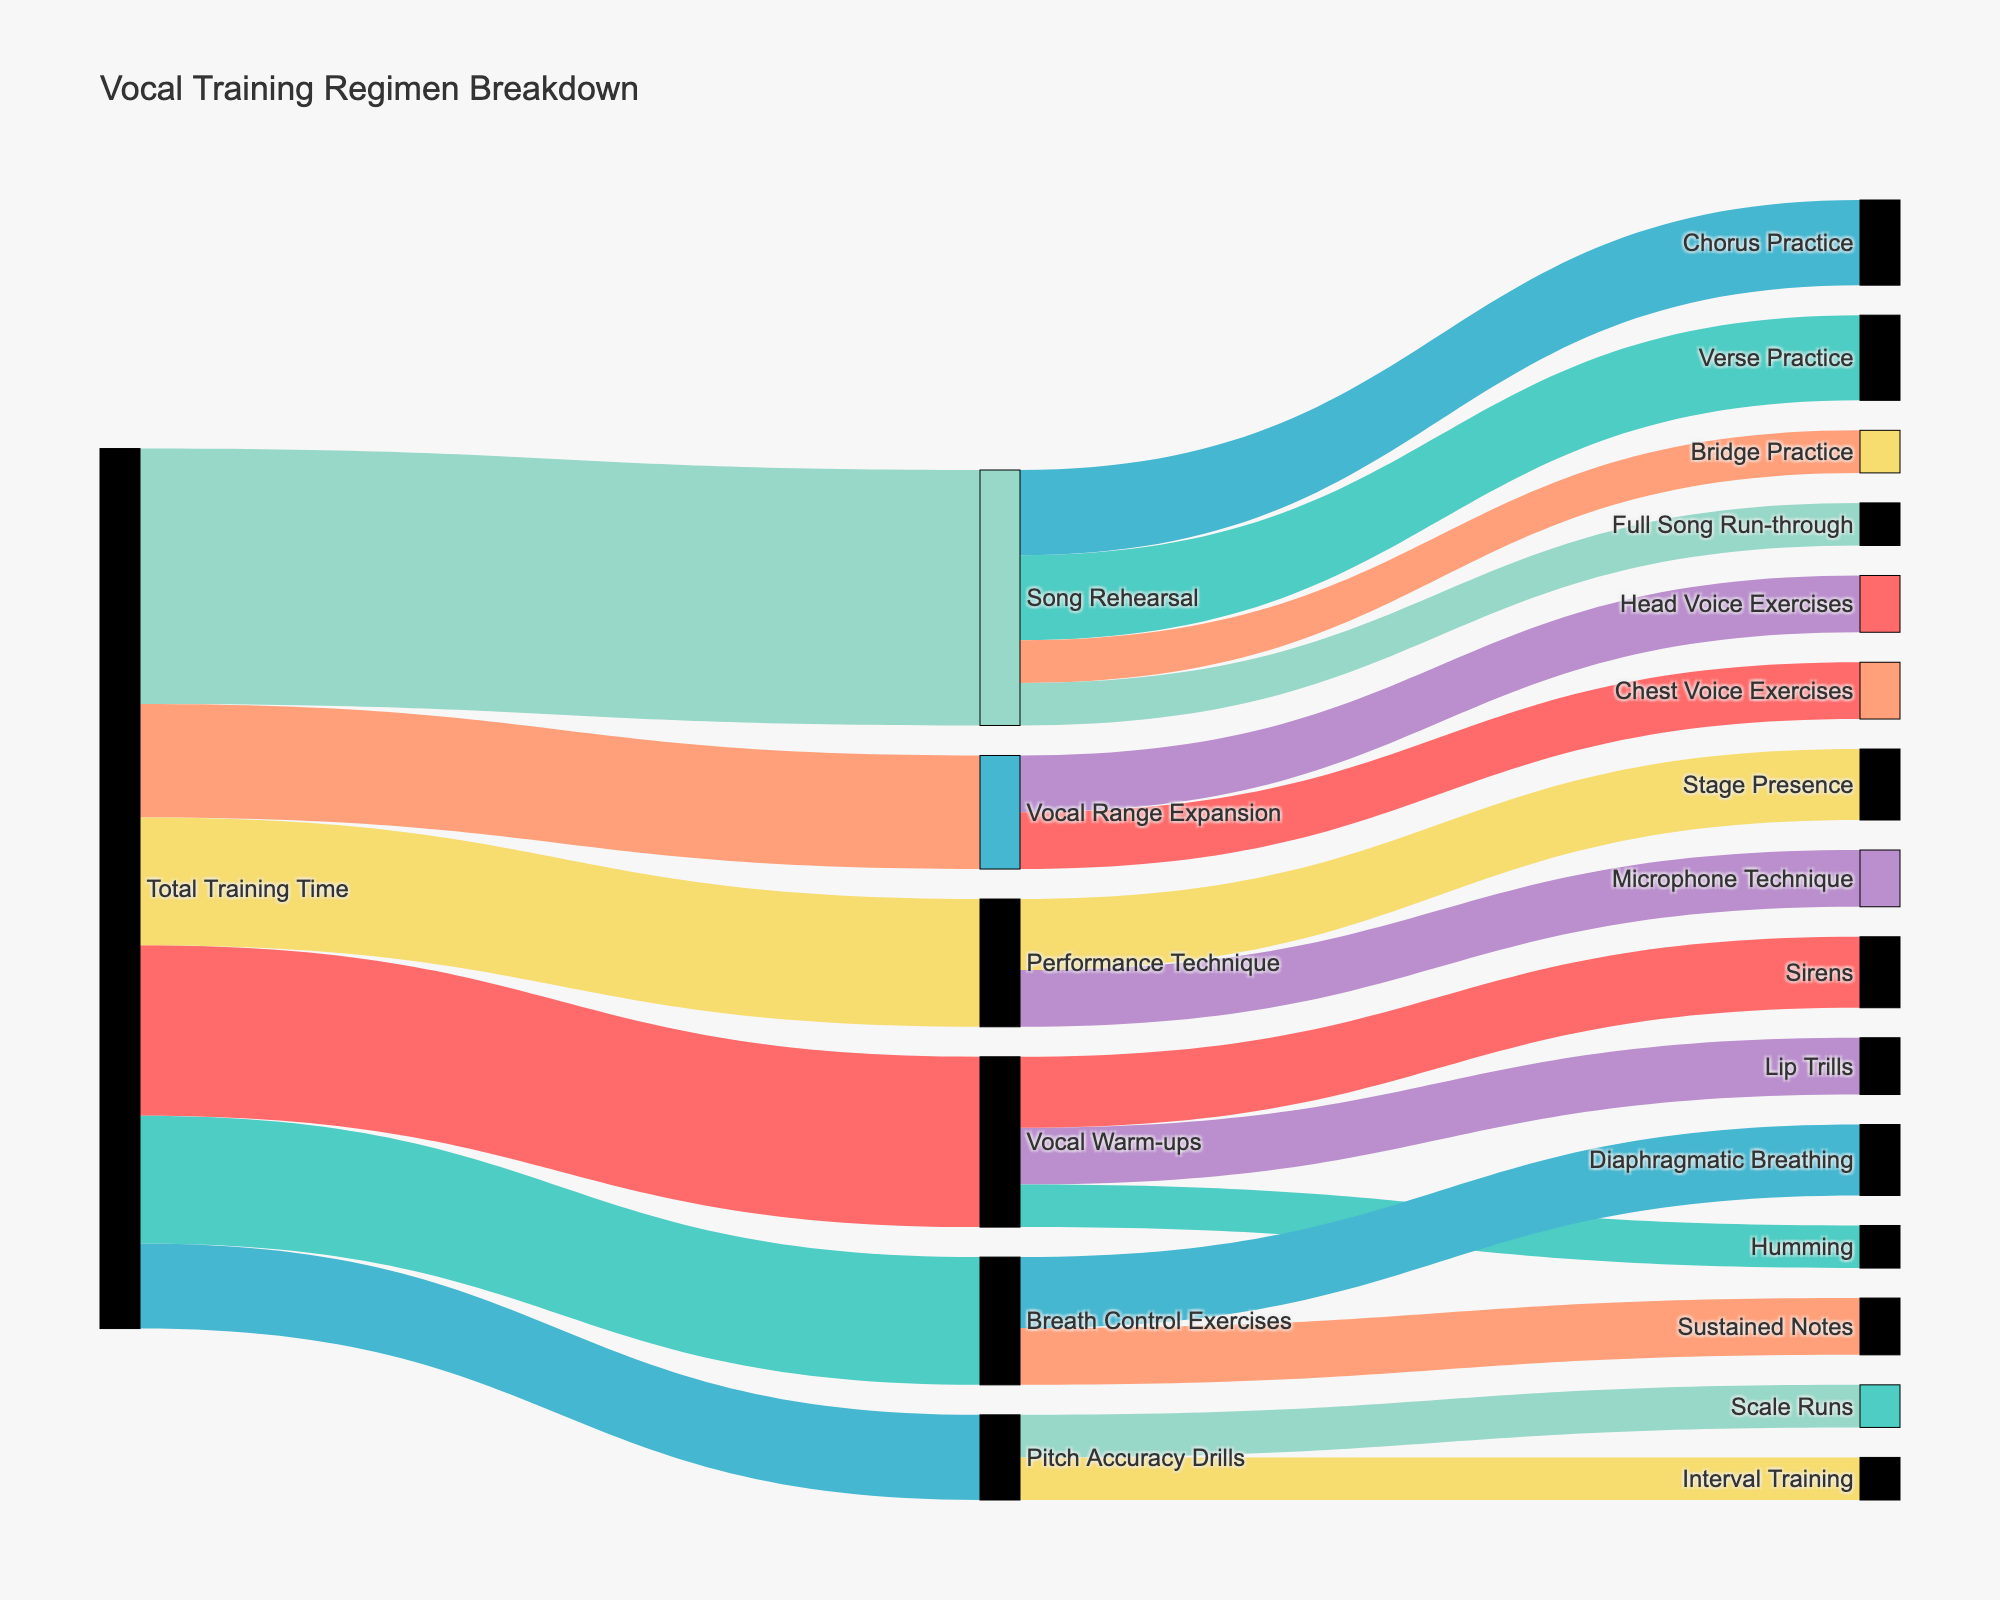what is the total time allocated to Song Rehearsal? Review the "Total Training Time" node that splits into different activities. Sum the values leading into Song Rehearsal: Verse Practice (30), Chorus Practice (30), Bridge Practice (15), and Full Song Run-through (15); total is 30 + 30 + 15 + 15 = 90 minutes.
Answer: 90 minutes Which specific exercise takes the most time under Vocal Warm-ups? Look into the breakdown of Vocal Warm-ups, which splits into Lip Trills, Sirens, and Humming. The time for each is: Lip Trills (20), Sirens (25), and Humming (15). Sirens have the highest value of 25 minutes.
Answer: Sirens Compare the time allocated to Performance Technique and Breath Control Exercises. Which one has more time and by how much? Check the values assigned to Performance Technique (45 minutes) and Breath Control Exercises (45 minutes). Both are allocated the same time.
Answer: Equal, 0 minutes How much total time is dedicated to vocal techniques excluding Song Rehearsal and Performance Technique? Among the main techniques, exclude Song Rehearsal and Performance Technique. Sum the remaining: Vocal Warm-ups (60), Breath Control Exercises (45), Pitch Accuracy Drills (30), Vocal Range Expansion (40). Total is: 60 + 45 + 30 + 40 = 175 minutes.
Answer: 175 minutes What's the combined time set for Pitch Accuracy Drills and Vocal Range Expansion? Identify Pitch Accuracy Drills (30 minutes) and Vocal Range Expansion (40 minutes). Add both values: 30 + 40 = 70 minutes.
Answer: 70 minutes How does time allocated to Lip Trills compare with time allocated to Diaphragmatic Breathing? Check the values for Lip Trills (20 minutes) and Diaphragmatic Breathing (25 minutes). Diaphragmatic Breathing takes more time: 25 - 20 = 5 minutes.
Answer: Diaphragmatic Breathing, by 5 minutes Which sub-category under Song Rehearsal takes up the least amount of time? Check values for Verse Practice, Chorus Practice, Bridge Practice, and Full Song Run-through. The times are 30, 30, 15, and 15 respectively. Bridge Practice and Full Song Run-through both take the least amount of time: 15 minutes.
Answer: Bridge Practice and Full Song Run-through How much more time is the Total Training Time compared to the combination of Vocal Warm-ups and Breath Control Exercises? Sum Vocal Warm-ups (60) and Breath Control Exercises (45): 60 + 45 = 105 minutes. The Total Training Time is 310 minutes. The difference is 310 - 105 = 205 minutes.
Answer: 205 minutes If you prioritized only Pitch Accuracy Drills and Skip Vocal Range Expansion, by how much would your workload decrease? Vocal Range Expansion is 40 minutes. By skipping it, the decrease in workload is 40 minutes.
Answer: 40 minutes 